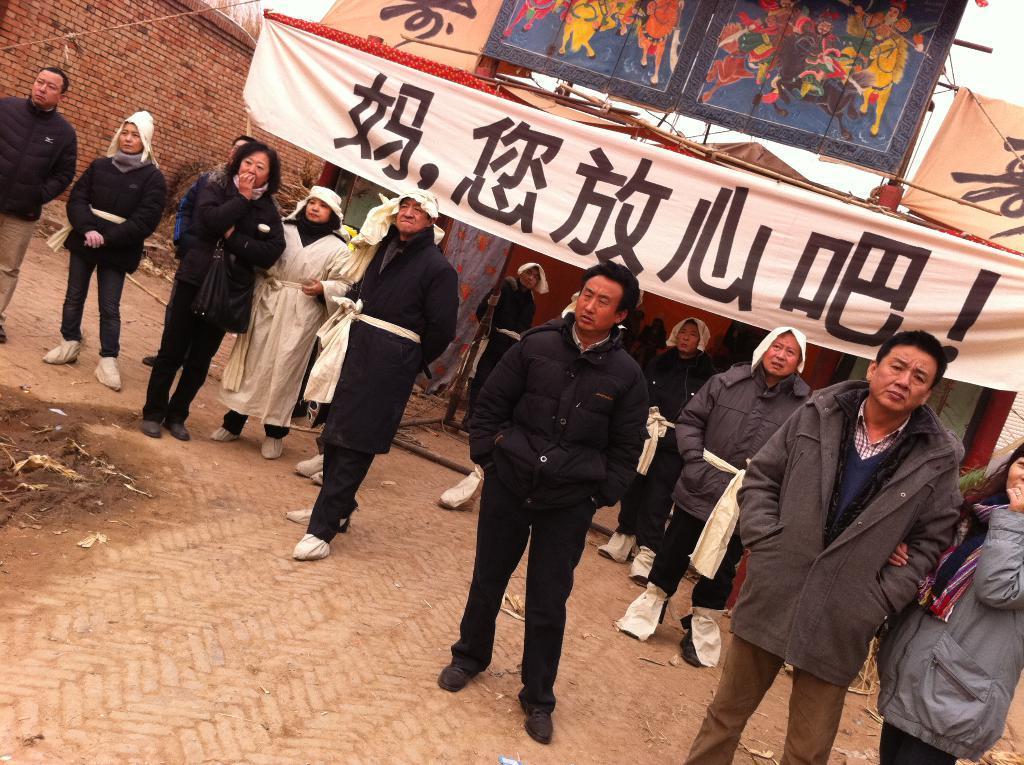Describe this image in one or two sentences. In the picture I can see group of people are standing on the ground. In the background I can see a banner which has something written on it, a brick wall and some other objects. 